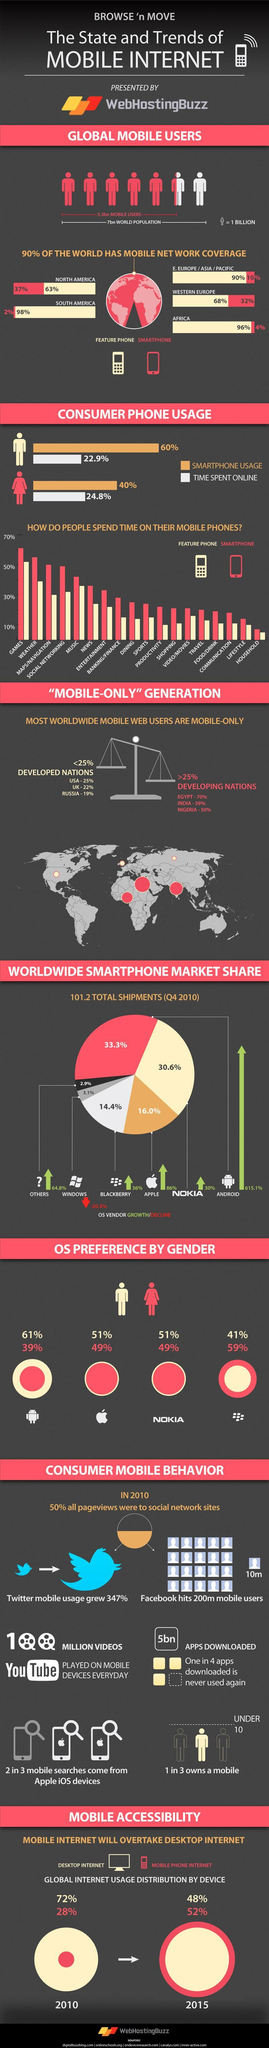Who among males or females spend higher amount of time online?
Answer the question with a short phrase. females Which continent has the lowest percentage of smart phone users ? South America Which continent has highest smart phone users, Western Europe , Eastern Europe or North America? North America What type of phones do most people in North America use? Feature Phone Which activity is has the second lowest percentage among feature phone users? Productivity Who uses larger percentage of smartphones men or women? men What is the total percentage of smart phone users in Africa and South America? 8% For which activity do most smart phone users use their phones for more than 40% of the time? Music Which activity ranks highest among both feature and smart phone users? Games 